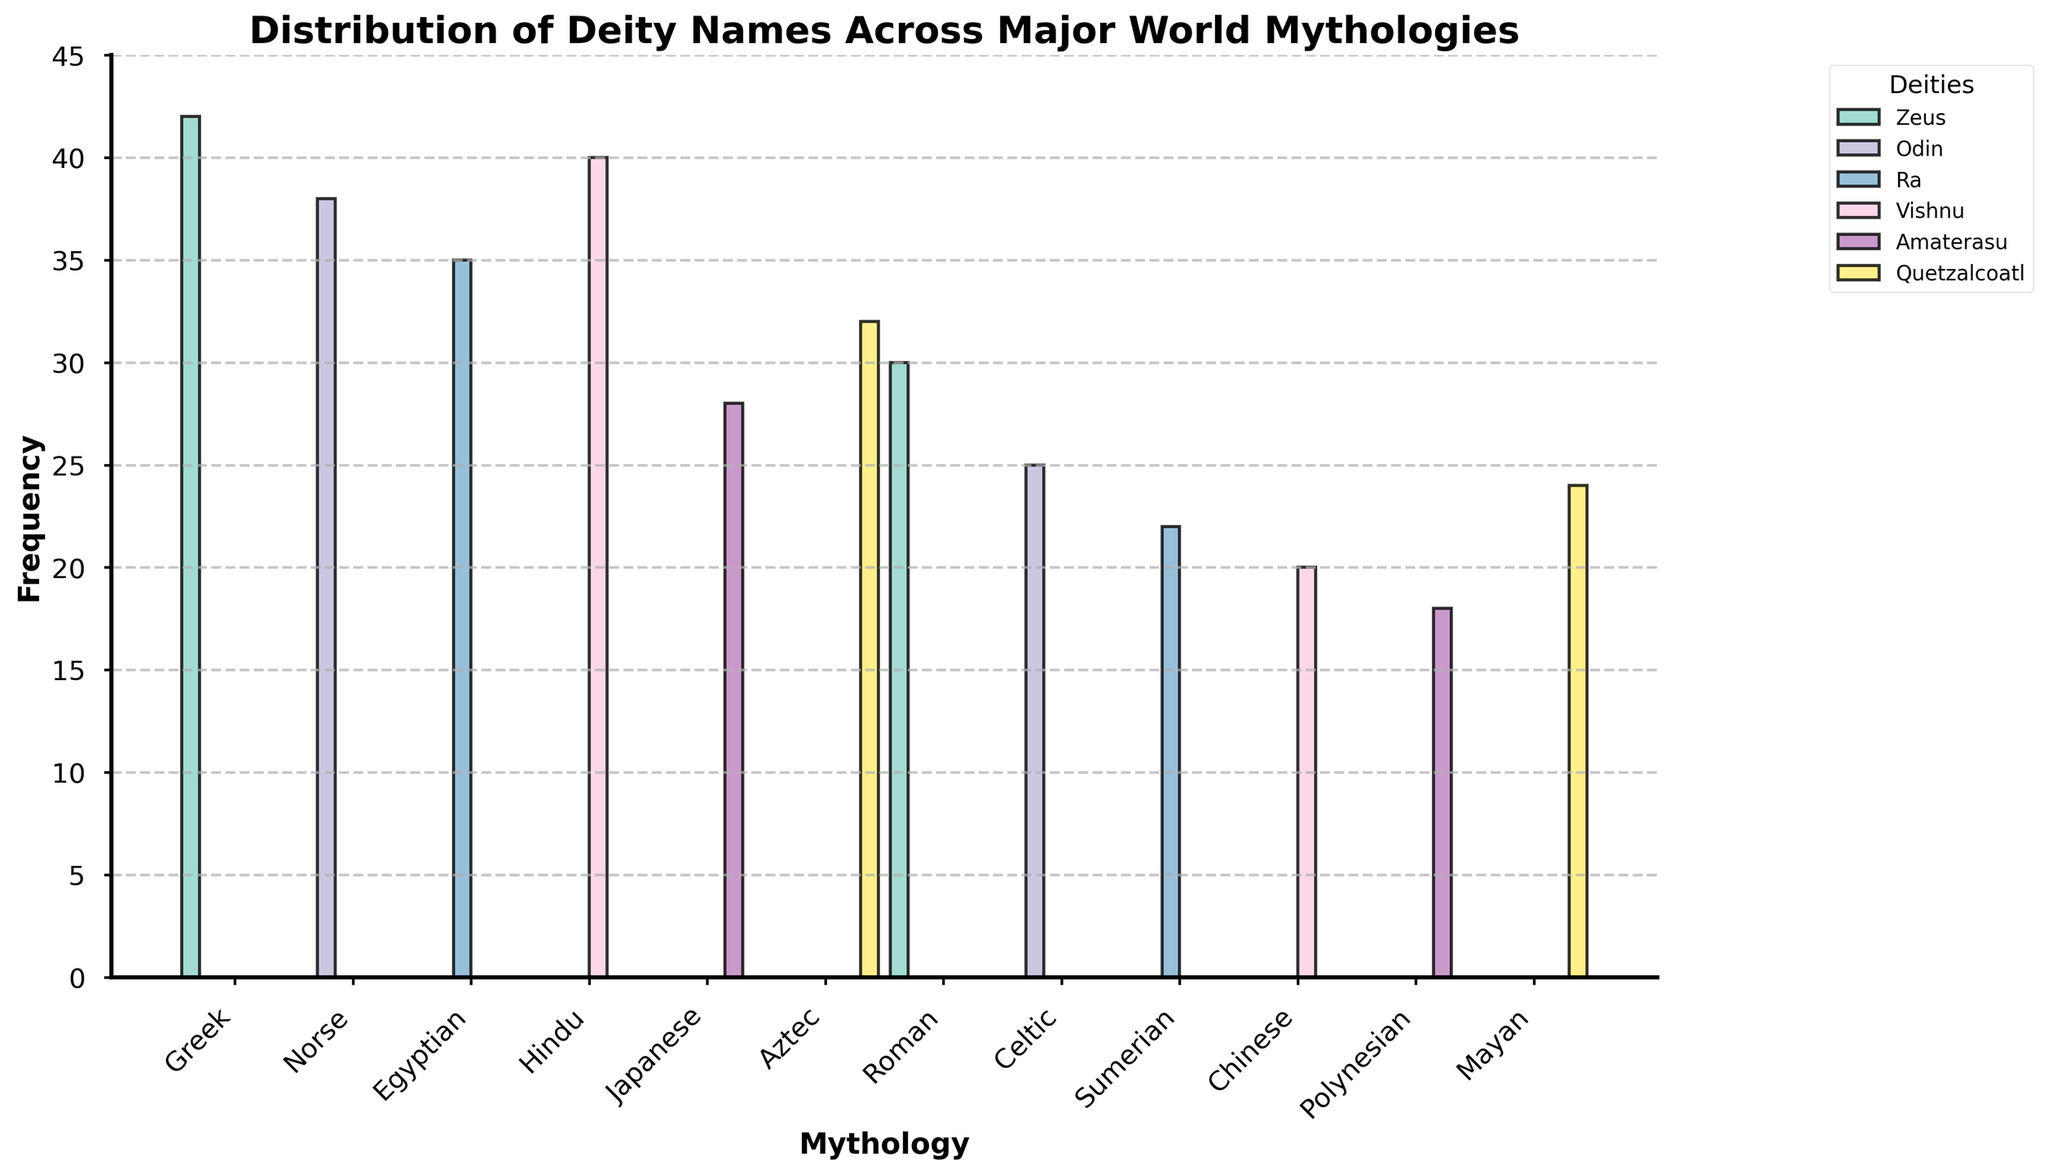Which mythology features the highest frequency of the god Zeus? In the figure, we can see that the Greek mythology has the highest frequency of the god Zeus, denoted by the tallest bar in the Greek category.
Answer: Greek Which deity shows up most frequently in Norse mythology? By observing the Norse category in the figure, we see that the deity Odin has the highest frequency, as represented by the tallest bar.
Answer: Odin How many more occurrences of Zeus are there in Greek mythology compared to Roman mythology? The bar for Zeus in Greek mythology reaches 42, while in Roman mythology it reaches 30. The difference is calculated as 42 - 30.
Answer: 12 Which two mythologies have similar frequencies for the deity Vishnu? The bars for Hindu and Chinese mythologies appear to be around the same height for the frequency of Vishnu. The respective frequencies are 40 and 20.
Answer: Hindu and Chinese Which mythology has the fewest deity names listed in the plot? By comparing the heights of the bars across all mythologies, Japanese and Polynesian have the smallest values, specifically around 18 and 28 respectively. The mythology featuring the fewest names is Polynesian.
Answer: Polynesian Rank the mythologies that feature Odin by their frequency, from highest to lowest. Odin appears in Norse with a frequency of 38, and in Celtic with a frequency of 25. Arranging them in order we get 38 (Norse) and 25 (Celtic).
Answer: Norse, Celtic How does the frequency of Ra in Egyptian mythology compare to the frequency of Quetzalcoatl in Aztec mythology? The bar representing Ra in Egyptian mythology shows a frequency of 35 while the bar representing Quetzalcoatl in Aztec mythology shows a frequency of 32. We see that Ra appears slightly more frequently.
Answer: Ra is higher than Quetzalcoatl What's the average frequency of the deity names listed in the Japanese and Mayan mythologies? In the plot, the value for Amaterasu in Japanese mythology is 28 and for Quetzalcoatl in Mayan mythology is 24. The average is calculated as (28 + 24) / 2.
Answer: 26 How many total occurrences are there for the deities associated with Zeus across all mythologies? The deities associated with Zeus include the Greek (42) and Roman (30) categories. The total occurrences are the sum of these values, which is 42 + 30.
Answer: 72 